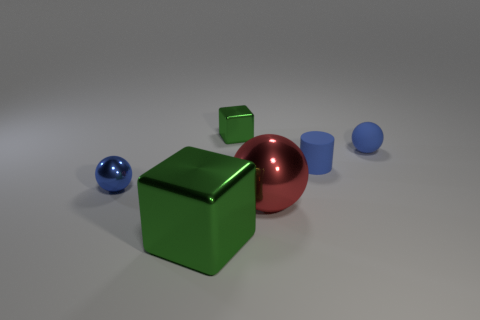Can you tell me the total number of objects in the image? Certainly! Within the image, there are a total of five objects: a large green cube, a smaller green cube, a red sphere, a blue sphere, and a blue cylinder.  Which object appears to be the largest? The largest object in the image is the green cube, which displays a considerable size in comparison to the other figures present. 